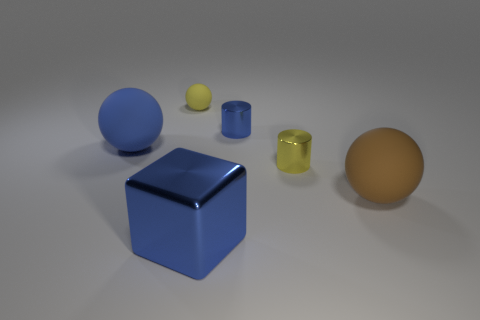Add 4 large blue objects. How many objects exist? 10 Subtract all blocks. How many objects are left? 5 Subtract all tiny blue cylinders. Subtract all yellow things. How many objects are left? 3 Add 2 big blue blocks. How many big blue blocks are left? 3 Add 3 tiny balls. How many tiny balls exist? 4 Subtract 0 cyan cylinders. How many objects are left? 6 